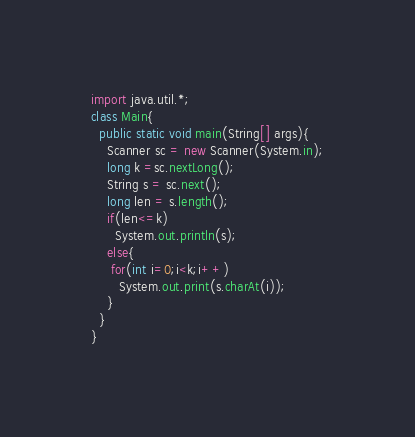<code> <loc_0><loc_0><loc_500><loc_500><_Java_>import java.util.*;
class Main{
  public static void main(String[] args){
    Scanner sc = new Scanner(System.in);
    long k =sc.nextLong();
    String s = sc.next();
    long len = s.length();
    if(len<=k)
      System.out.println(s);
    else{
     for(int i=0;i<k;i++)
       System.out.print(s.charAt(i));
    }
  }
}</code> 